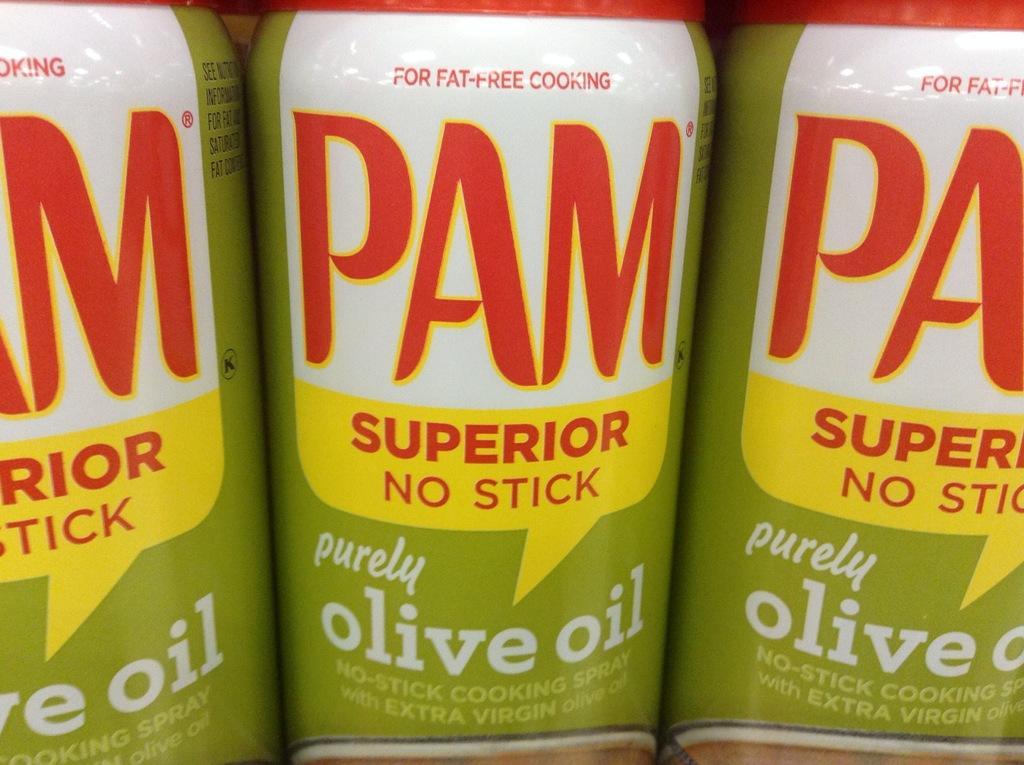Could you give a brief overview of what you see in this image? In this image we can see there are bottles and text written on it. 